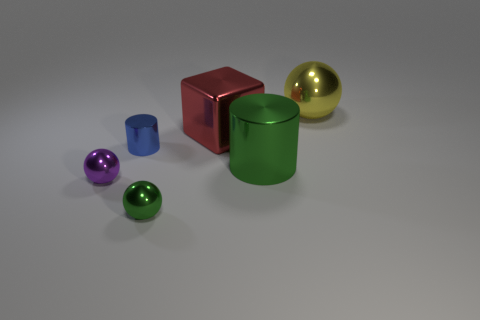What material is the small green object that is the same shape as the yellow shiny thing?
Your answer should be very brief. Metal. Is the shape of the tiny purple object the same as the small blue thing?
Give a very brief answer. No. There is a ball behind the green cylinder; what number of big green objects are right of it?
Provide a short and direct response. 0. The blue object that is the same material as the tiny green sphere is what shape?
Keep it short and to the point. Cylinder. What number of yellow objects are tiny metal balls or big shiny cubes?
Keep it short and to the point. 0. Are there any metal objects to the right of the shiny cylinder that is to the right of the small metal ball that is in front of the tiny purple shiny sphere?
Your answer should be compact. Yes. Is the number of tiny gray metal blocks less than the number of green objects?
Provide a short and direct response. Yes. Is the shape of the green object right of the small green thing the same as  the purple object?
Make the answer very short. No. Is there a purple shiny sphere?
Offer a terse response. Yes. There is a big metal object that is in front of the small metal object behind the metallic cylinder that is right of the big metallic cube; what color is it?
Offer a very short reply. Green. 